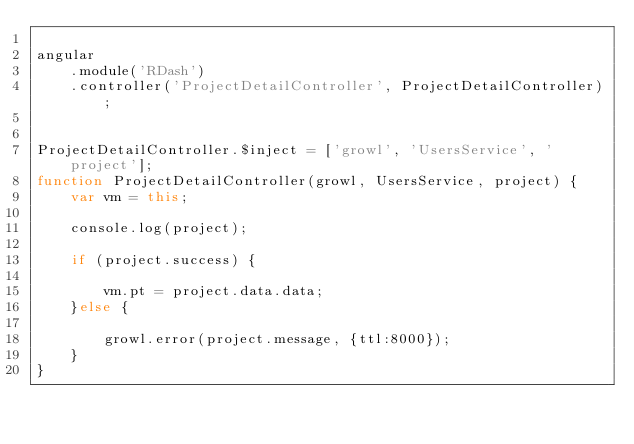Convert code to text. <code><loc_0><loc_0><loc_500><loc_500><_JavaScript_>
angular
    .module('RDash')
    .controller('ProjectDetailController', ProjectDetailController);


ProjectDetailController.$inject = ['growl', 'UsersService', 'project'];
function ProjectDetailController(growl, UsersService, project) {
    var vm = this;

    console.log(project);

    if (project.success) {

        vm.pt = project.data.data;
    }else {

        growl.error(project.message, {ttl:8000});
    }
}</code> 